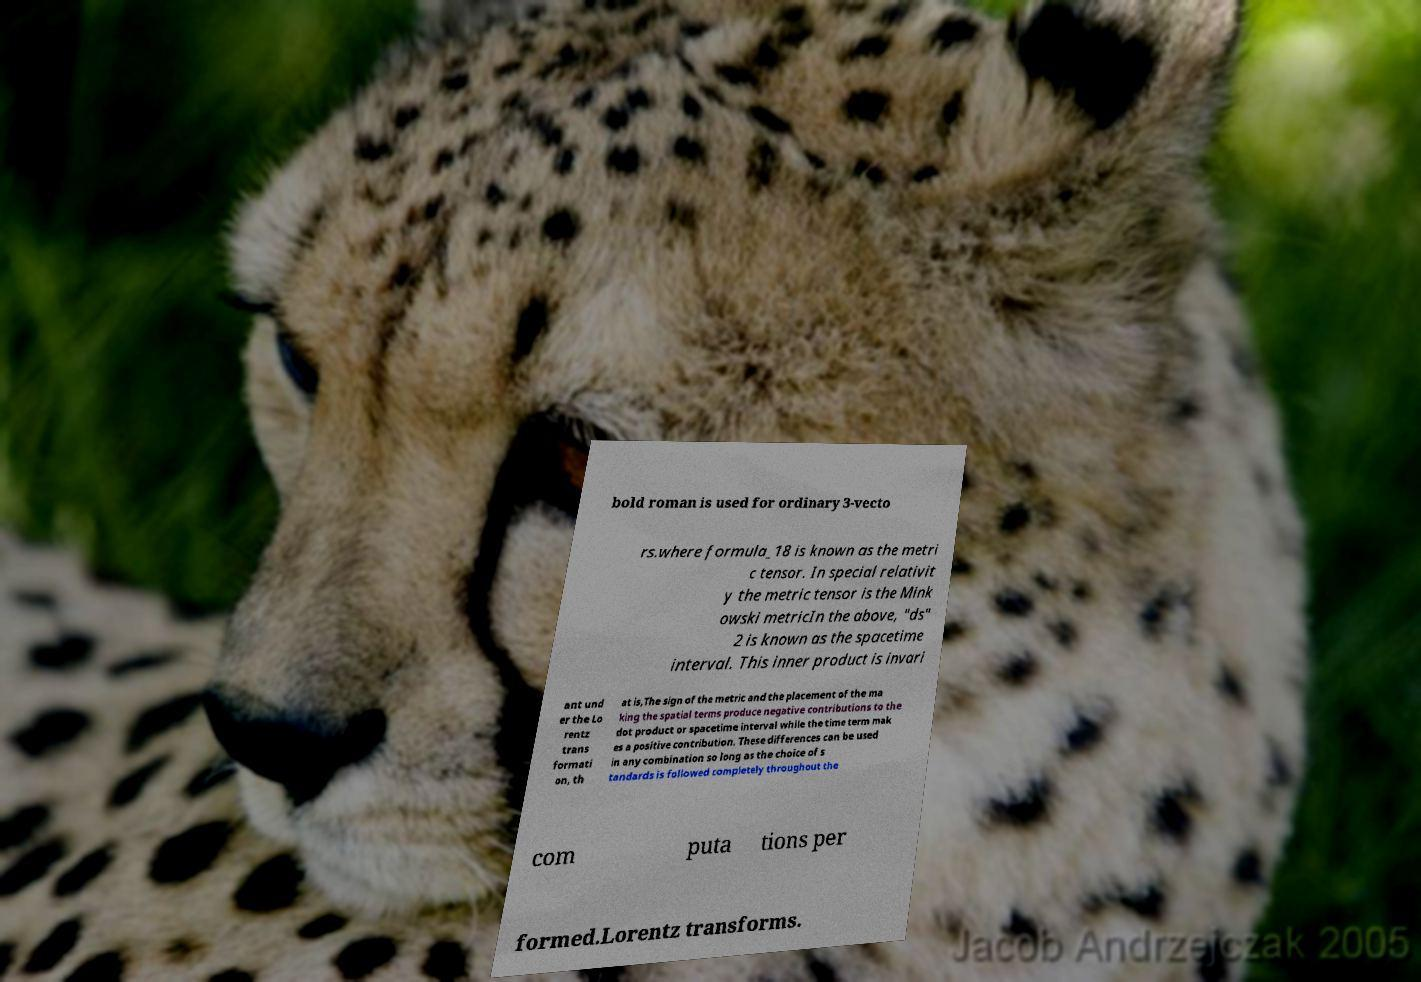Can you accurately transcribe the text from the provided image for me? bold roman is used for ordinary 3-vecto rs.where formula_18 is known as the metri c tensor. In special relativit y the metric tensor is the Mink owski metricIn the above, "ds" 2 is known as the spacetime interval. This inner product is invari ant und er the Lo rentz trans formati on, th at is,The sign of the metric and the placement of the ma king the spatial terms produce negative contributions to the dot product or spacetime interval while the time term mak es a positive contribution. These differences can be used in any combination so long as the choice of s tandards is followed completely throughout the com puta tions per formed.Lorentz transforms. 